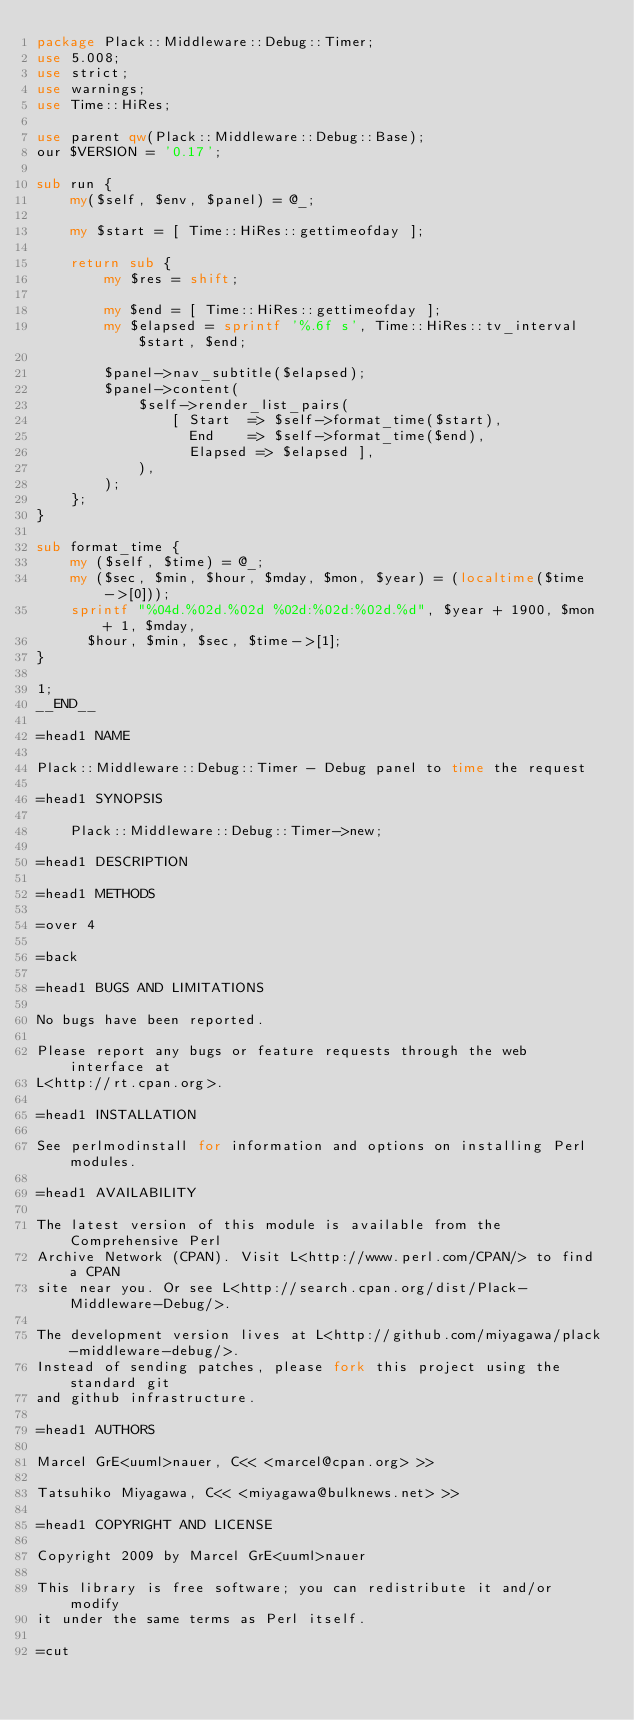<code> <loc_0><loc_0><loc_500><loc_500><_Perl_>package Plack::Middleware::Debug::Timer;
use 5.008;
use strict;
use warnings;
use Time::HiRes;

use parent qw(Plack::Middleware::Debug::Base);
our $VERSION = '0.17';

sub run {
    my($self, $env, $panel) = @_;

    my $start = [ Time::HiRes::gettimeofday ];

    return sub {
        my $res = shift;

        my $end = [ Time::HiRes::gettimeofday ];
        my $elapsed = sprintf '%.6f s', Time::HiRes::tv_interval $start, $end;

        $panel->nav_subtitle($elapsed);
        $panel->content(
            $self->render_list_pairs(
                [ Start  => $self->format_time($start),
                  End    => $self->format_time($end),
                  Elapsed => $elapsed ],
            ),
        );
    };
}

sub format_time {
    my ($self, $time) = @_;
    my ($sec, $min, $hour, $mday, $mon, $year) = (localtime($time->[0]));
    sprintf "%04d.%02d.%02d %02d:%02d:%02d.%d", $year + 1900, $mon + 1, $mday,
      $hour, $min, $sec, $time->[1];
}

1;
__END__

=head1 NAME

Plack::Middleware::Debug::Timer - Debug panel to time the request

=head1 SYNOPSIS

    Plack::Middleware::Debug::Timer->new;

=head1 DESCRIPTION

=head1 METHODS

=over 4

=back

=head1 BUGS AND LIMITATIONS

No bugs have been reported.

Please report any bugs or feature requests through the web interface at
L<http://rt.cpan.org>.

=head1 INSTALLATION

See perlmodinstall for information and options on installing Perl modules.

=head1 AVAILABILITY

The latest version of this module is available from the Comprehensive Perl
Archive Network (CPAN). Visit L<http://www.perl.com/CPAN/> to find a CPAN
site near you. Or see L<http://search.cpan.org/dist/Plack-Middleware-Debug/>.

The development version lives at L<http://github.com/miyagawa/plack-middleware-debug/>.
Instead of sending patches, please fork this project using the standard git
and github infrastructure.

=head1 AUTHORS

Marcel GrE<uuml>nauer, C<< <marcel@cpan.org> >>

Tatsuhiko Miyagawa, C<< <miyagawa@bulknews.net> >>

=head1 COPYRIGHT AND LICENSE

Copyright 2009 by Marcel GrE<uuml>nauer

This library is free software; you can redistribute it and/or modify
it under the same terms as Perl itself.

=cut
</code> 